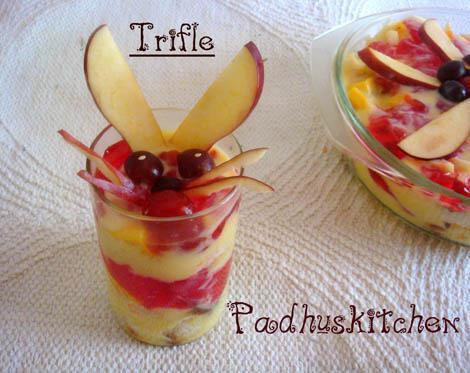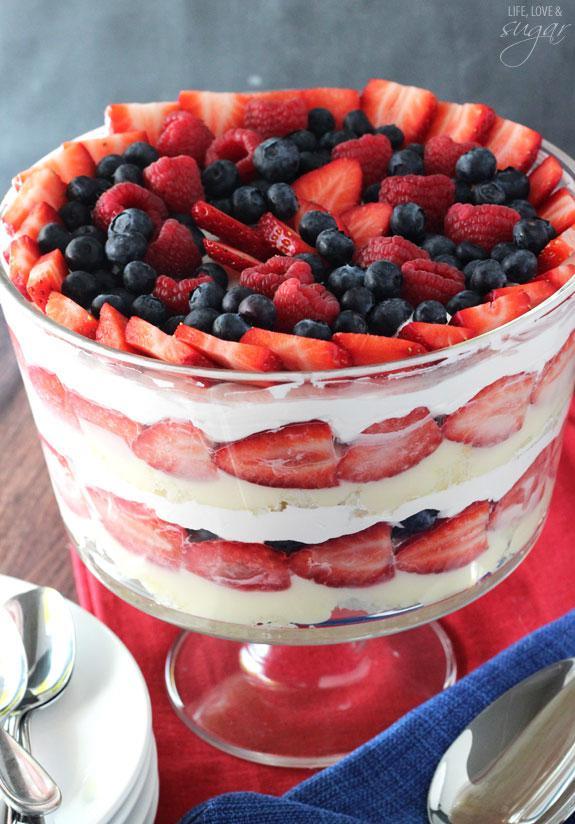The first image is the image on the left, the second image is the image on the right. Considering the images on both sides, is "The left image features a trifle garnished with thin apple slices." valid? Answer yes or no. Yes. 